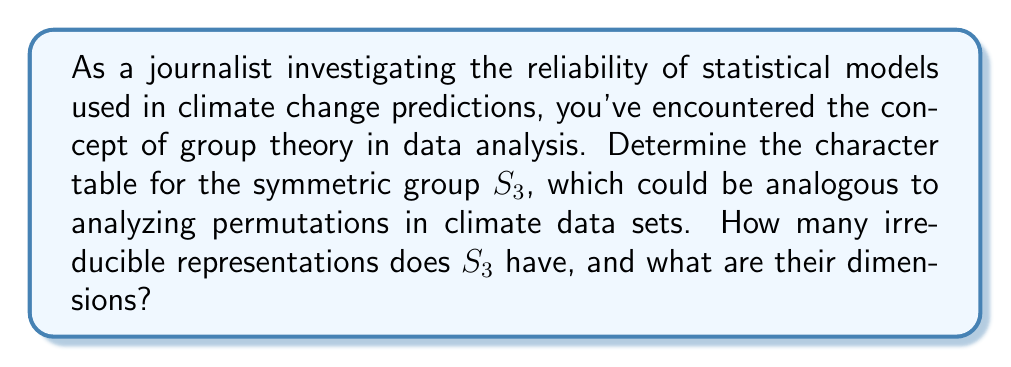Show me your answer to this math problem. Let's approach this step-by-step:

1) First, we need to identify the conjugacy classes of $S_3$:
   - Identity: $e = (1)$
   - Transpositions: $(12)$, $(13)$, $(23)$
   - 3-cycles: $(123)$, $(132)$

   There are 3 conjugacy classes: $\{e\}$, $\{(12),(13),(23)\}$, and $\{(123),(132)\}$.

2) The number of irreducible representations equals the number of conjugacy classes. So, $S_3$ has 3 irreducible representations.

3) To determine the dimensions of these representations, we use the formula:
   $$\sum_{i=1}^{k} d_i^2 = |G|$$
   where $k$ is the number of irreducible representations, $d_i$ are their dimensions, and $|G|$ is the order of the group.

4) We know $|S_3| = 6$. Let the dimensions be $d_1$, $d_2$, and $d_3$. Then:
   $$d_1^2 + d_2^2 + d_3^2 = 6$$

5) We know there's always a trivial representation of dimension 1, so $d_1 = 1$.

6) The sign representation is also 1-dimensional, so $d_2 = 1$.

7) Substituting in our equation:
   $$1^2 + 1^2 + d_3^2 = 6$$
   $$d_3^2 = 4$$
   $$d_3 = 2$$

8) Now we can construct the character table:

   $$\begin{array}{c|ccc}
    S_3 & e & (12) & (123) \\
   \hline
   \chi_1 & 1 & 1 & 1 \\
   \chi_2 & 1 & -1 & 1 \\
   \chi_3 & 2 & 0 & -1
   \end{array}$$

   Where $\chi_1$ is the trivial representation, $\chi_2$ is the sign representation, and $\chi_3$ is the 2-dimensional representation.
Answer: $S_3$ has 3 irreducible representations of dimensions 1, 1, and 2. 